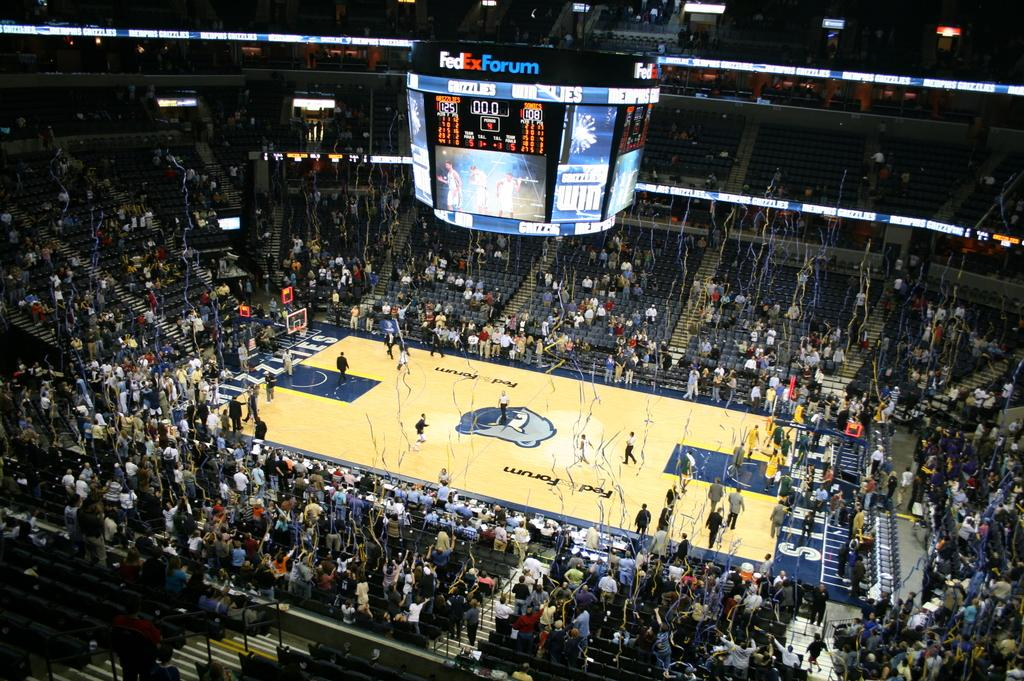<image>
Describe the image concisely. The scoreboard  has the words FedEX Forum on top of it 